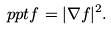<formula> <loc_0><loc_0><loc_500><loc_500>\ p p t f = | \nabla f | ^ { 2 } .</formula> 